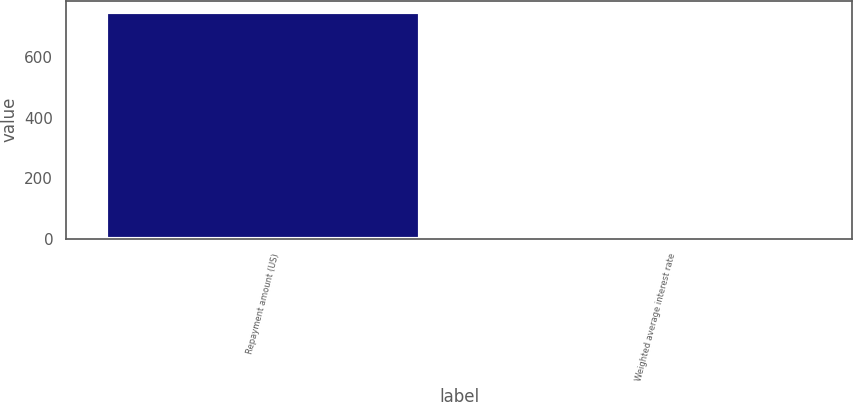Convert chart. <chart><loc_0><loc_0><loc_500><loc_500><bar_chart><fcel>Repayment amount (US)<fcel>Weighted average interest rate<nl><fcel>750<fcel>5.5<nl></chart> 